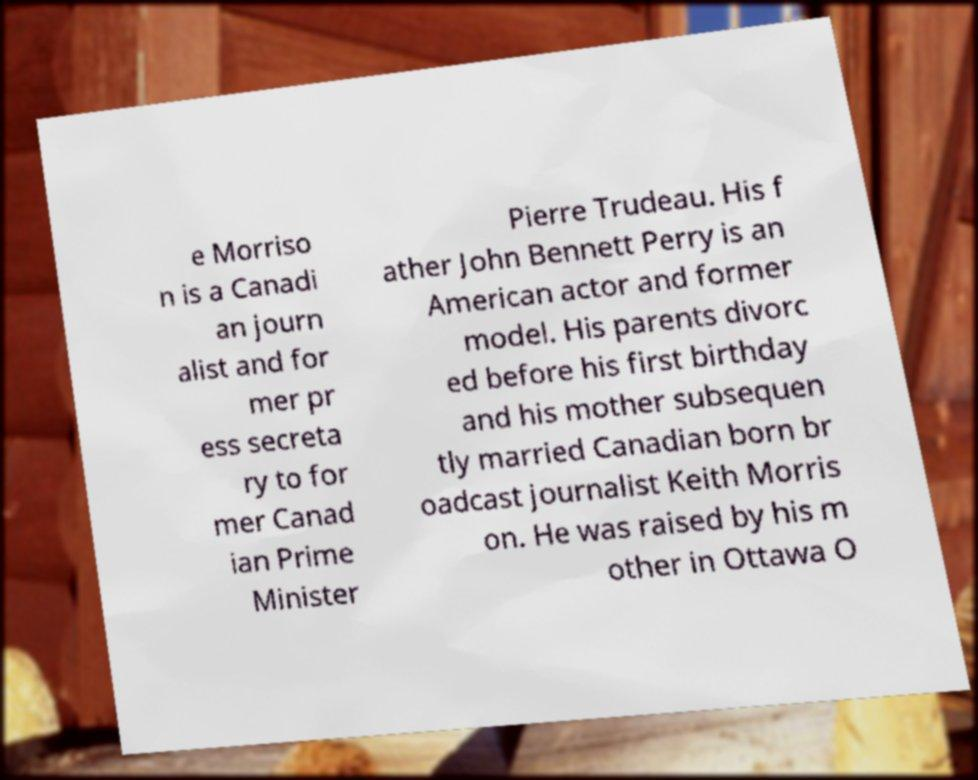Please read and relay the text visible in this image. What does it say? e Morriso n is a Canadi an journ alist and for mer pr ess secreta ry to for mer Canad ian Prime Minister Pierre Trudeau. His f ather John Bennett Perry is an American actor and former model. His parents divorc ed before his first birthday and his mother subsequen tly married Canadian born br oadcast journalist Keith Morris on. He was raised by his m other in Ottawa O 